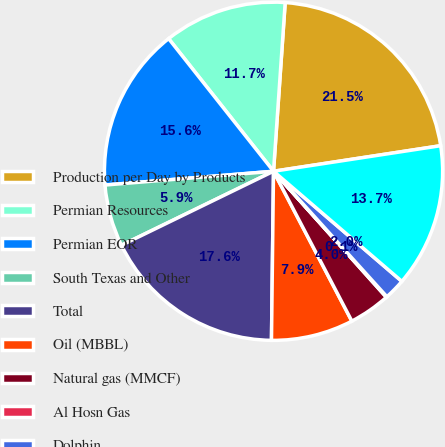Convert chart to OTSL. <chart><loc_0><loc_0><loc_500><loc_500><pie_chart><fcel>Production per Day by Products<fcel>Permian Resources<fcel>Permian EOR<fcel>South Texas and Other<fcel>Total<fcel>Oil (MBBL)<fcel>Natural gas (MMCF)<fcel>Al Hosn Gas<fcel>Dolphin<fcel>Oman<nl><fcel>21.49%<fcel>11.75%<fcel>15.65%<fcel>5.91%<fcel>17.6%<fcel>7.86%<fcel>3.96%<fcel>0.07%<fcel>2.02%<fcel>13.7%<nl></chart> 